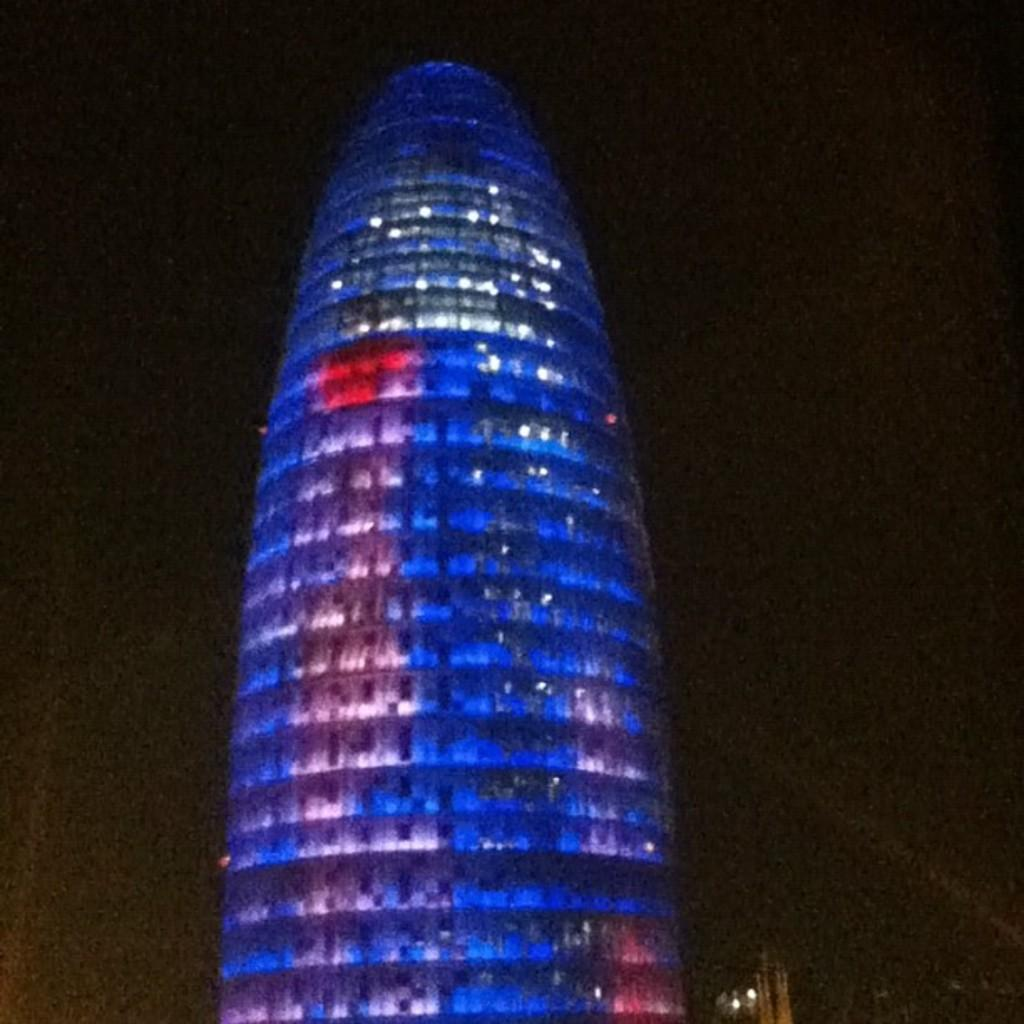What type of structure is visible in the image? There is a building in the image. How many icicles are hanging from the building in the image? There is no mention of icicles in the provided fact, so we cannot determine if any are present or how many there might be. 